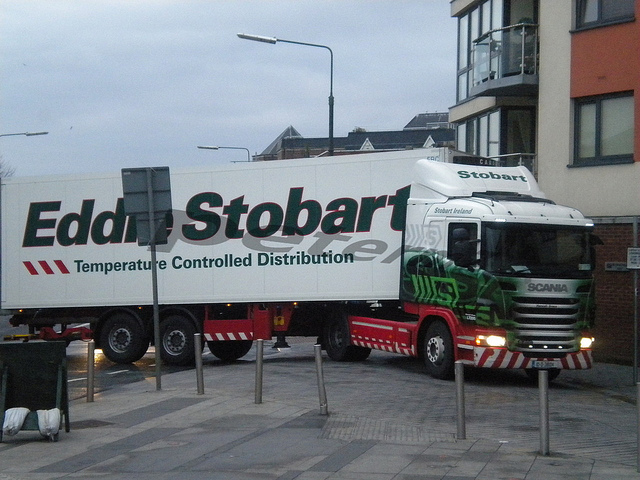What kind of environment or setting does the image depict? The surroundings in the picture suggest an urban setting, likely on the outskirts of a city or in a commercial district. The presence of modern buildings, street lamps, and pavement indicate that the truck is navigating through a built-up area, possibly approaching a delivery location or highway. 